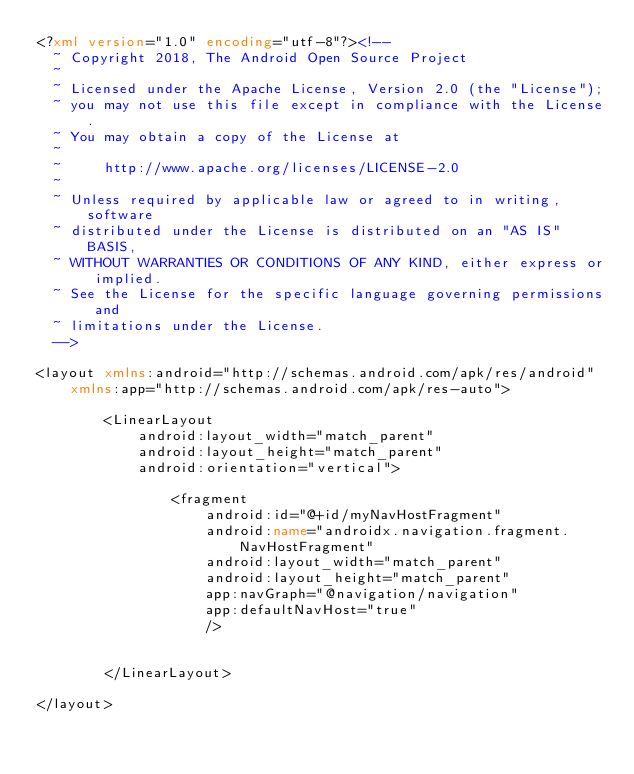Convert code to text. <code><loc_0><loc_0><loc_500><loc_500><_XML_><?xml version="1.0" encoding="utf-8"?><!--
  ~ Copyright 2018, The Android Open Source Project
  ~
  ~ Licensed under the Apache License, Version 2.0 (the "License");
  ~ you may not use this file except in compliance with the License.
  ~ You may obtain a copy of the License at
  ~
  ~     http://www.apache.org/licenses/LICENSE-2.0
  ~
  ~ Unless required by applicable law or agreed to in writing, software
  ~ distributed under the License is distributed on an "AS IS" BASIS,
  ~ WITHOUT WARRANTIES OR CONDITIONS OF ANY KIND, either express or implied.
  ~ See the License for the specific language governing permissions and
  ~ limitations under the License.
  -->

<layout xmlns:android="http://schemas.android.com/apk/res/android"
    xmlns:app="http://schemas.android.com/apk/res-auto">

        <LinearLayout
            android:layout_width="match_parent"
            android:layout_height="match_parent"
            android:orientation="vertical">

                <fragment
                    android:id="@+id/myNavHostFragment"
                    android:name="androidx.navigation.fragment.NavHostFragment"
                    android:layout_width="match_parent"
                    android:layout_height="match_parent"
                    app:navGraph="@navigation/navigation"
                    app:defaultNavHost="true"
                    />


        </LinearLayout>

</layout>
</code> 